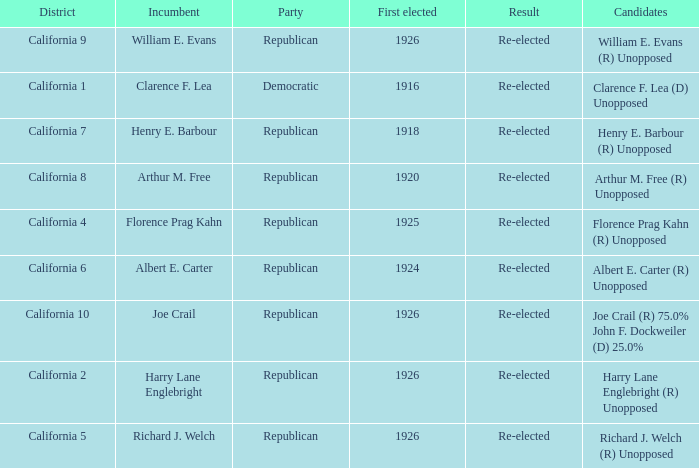What's the region with a party being democratic? California 1. 